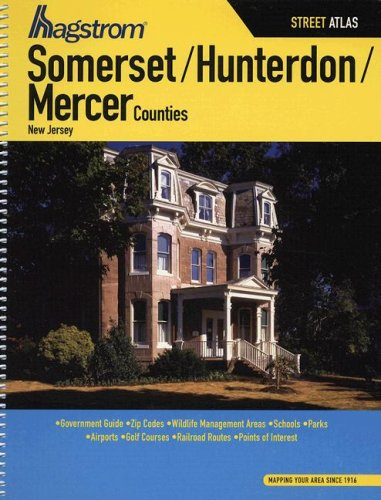Is this a journey related book? Yes, this book is related to journey and travel planning, especially useful for those looking to explore or navigate the counties of Somerset, Hunterdon, and Mercer in New Jersey. 